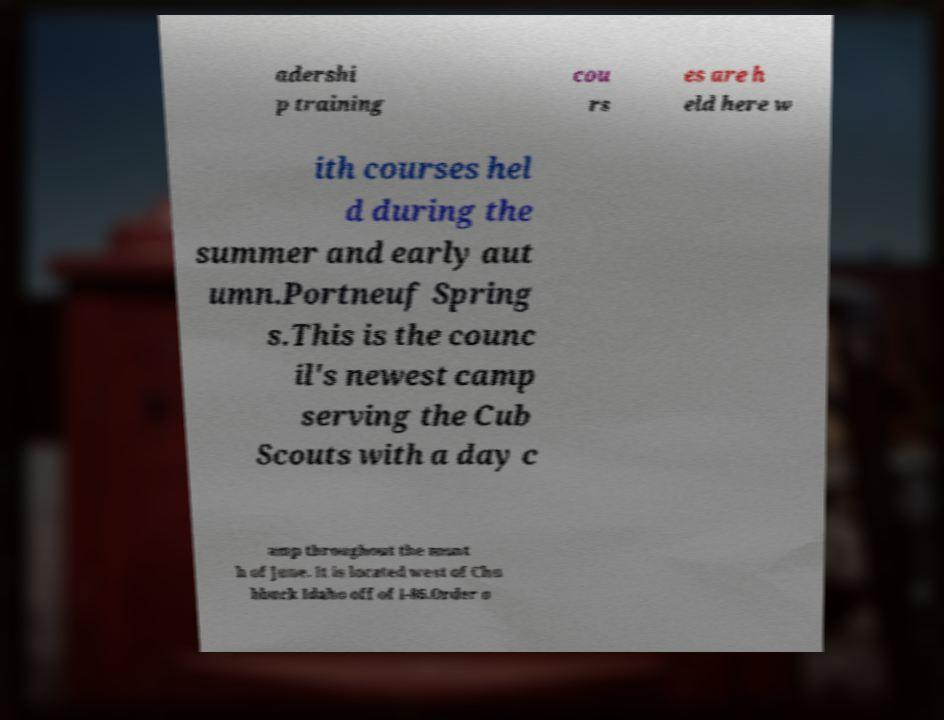What messages or text are displayed in this image? I need them in a readable, typed format. adershi p training cou rs es are h eld here w ith courses hel d during the summer and early aut umn.Portneuf Spring s.This is the counc il's newest camp serving the Cub Scouts with a day c amp throughout the mont h of June. It is located west of Chu bbuck Idaho off of I-86.Order o 